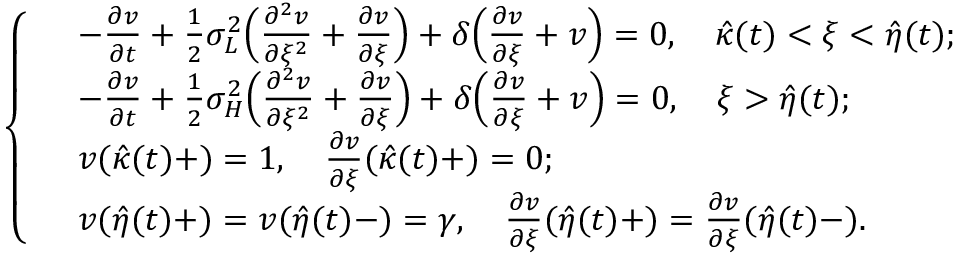<formula> <loc_0><loc_0><loc_500><loc_500>\left \{ \begin{array} { r l } & { - \frac { \partial v } { \partial t } + \frac { 1 } { 2 } \sigma _ { L } ^ { 2 } \left ( \frac { \partial ^ { 2 } v } { \partial \xi ^ { 2 } } + \frac { \partial v } { \partial \xi } \right ) + \delta \left ( \frac { \partial v } { \partial \xi } + v \right ) = 0 , \quad \hat { \kappa } ( t ) < \xi < \hat { \eta } ( t ) ; } \\ & { - \frac { \partial v } { \partial t } + \frac { 1 } { 2 } \sigma _ { H } ^ { 2 } \left ( \frac { \partial ^ { 2 } v } { \partial \xi ^ { 2 } } + \frac { \partial v } { \partial \xi } \right ) + \delta \left ( \frac { \partial v } { \partial \xi } + v \right ) = 0 , \quad \xi > \hat { \eta } ( t ) ; } \\ & { v ( \hat { \kappa } ( t ) + ) = 1 , \quad \frac { \partial v } { \partial \xi } ( \hat { \kappa } ( t ) + ) = 0 ; } \\ & { v ( \hat { \eta } ( t ) + ) = v ( \hat { \eta } ( t ) - ) = \gamma , \quad \frac { \partial v } { \partial \xi } ( \hat { \eta } ( t ) + ) = \frac { \partial v } { \partial \xi } ( \hat { \eta } ( t ) - ) . } \end{array}</formula> 